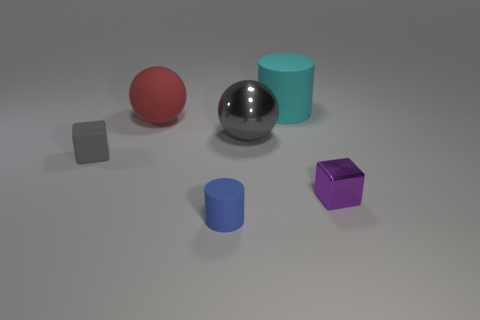Add 1 small gray balls. How many objects exist? 7 Subtract all gray balls. How many balls are left? 1 Subtract all blocks. How many objects are left? 4 Subtract 2 cubes. How many cubes are left? 0 Subtract all gray cubes. Subtract all purple cylinders. How many cubes are left? 1 Subtract all big red objects. Subtract all large gray spheres. How many objects are left? 4 Add 1 gray objects. How many gray objects are left? 3 Add 1 small red things. How many small red things exist? 1 Subtract 0 cyan cubes. How many objects are left? 6 